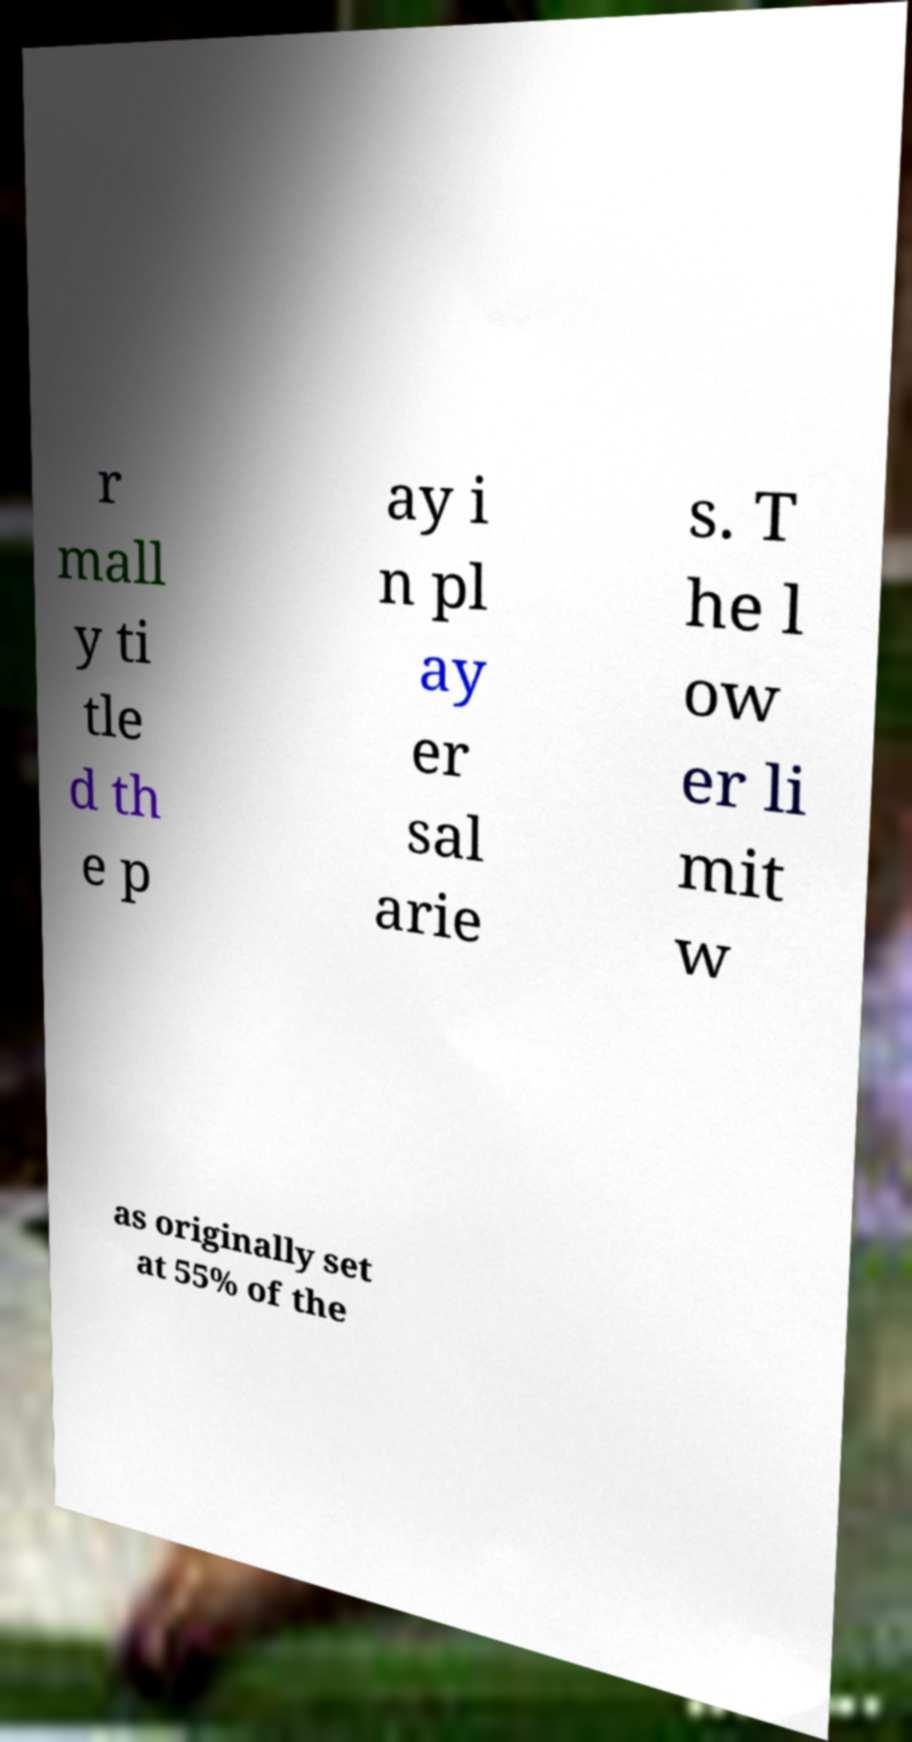I need the written content from this picture converted into text. Can you do that? r mall y ti tle d th e p ay i n pl ay er sal arie s. T he l ow er li mit w as originally set at 55% of the 